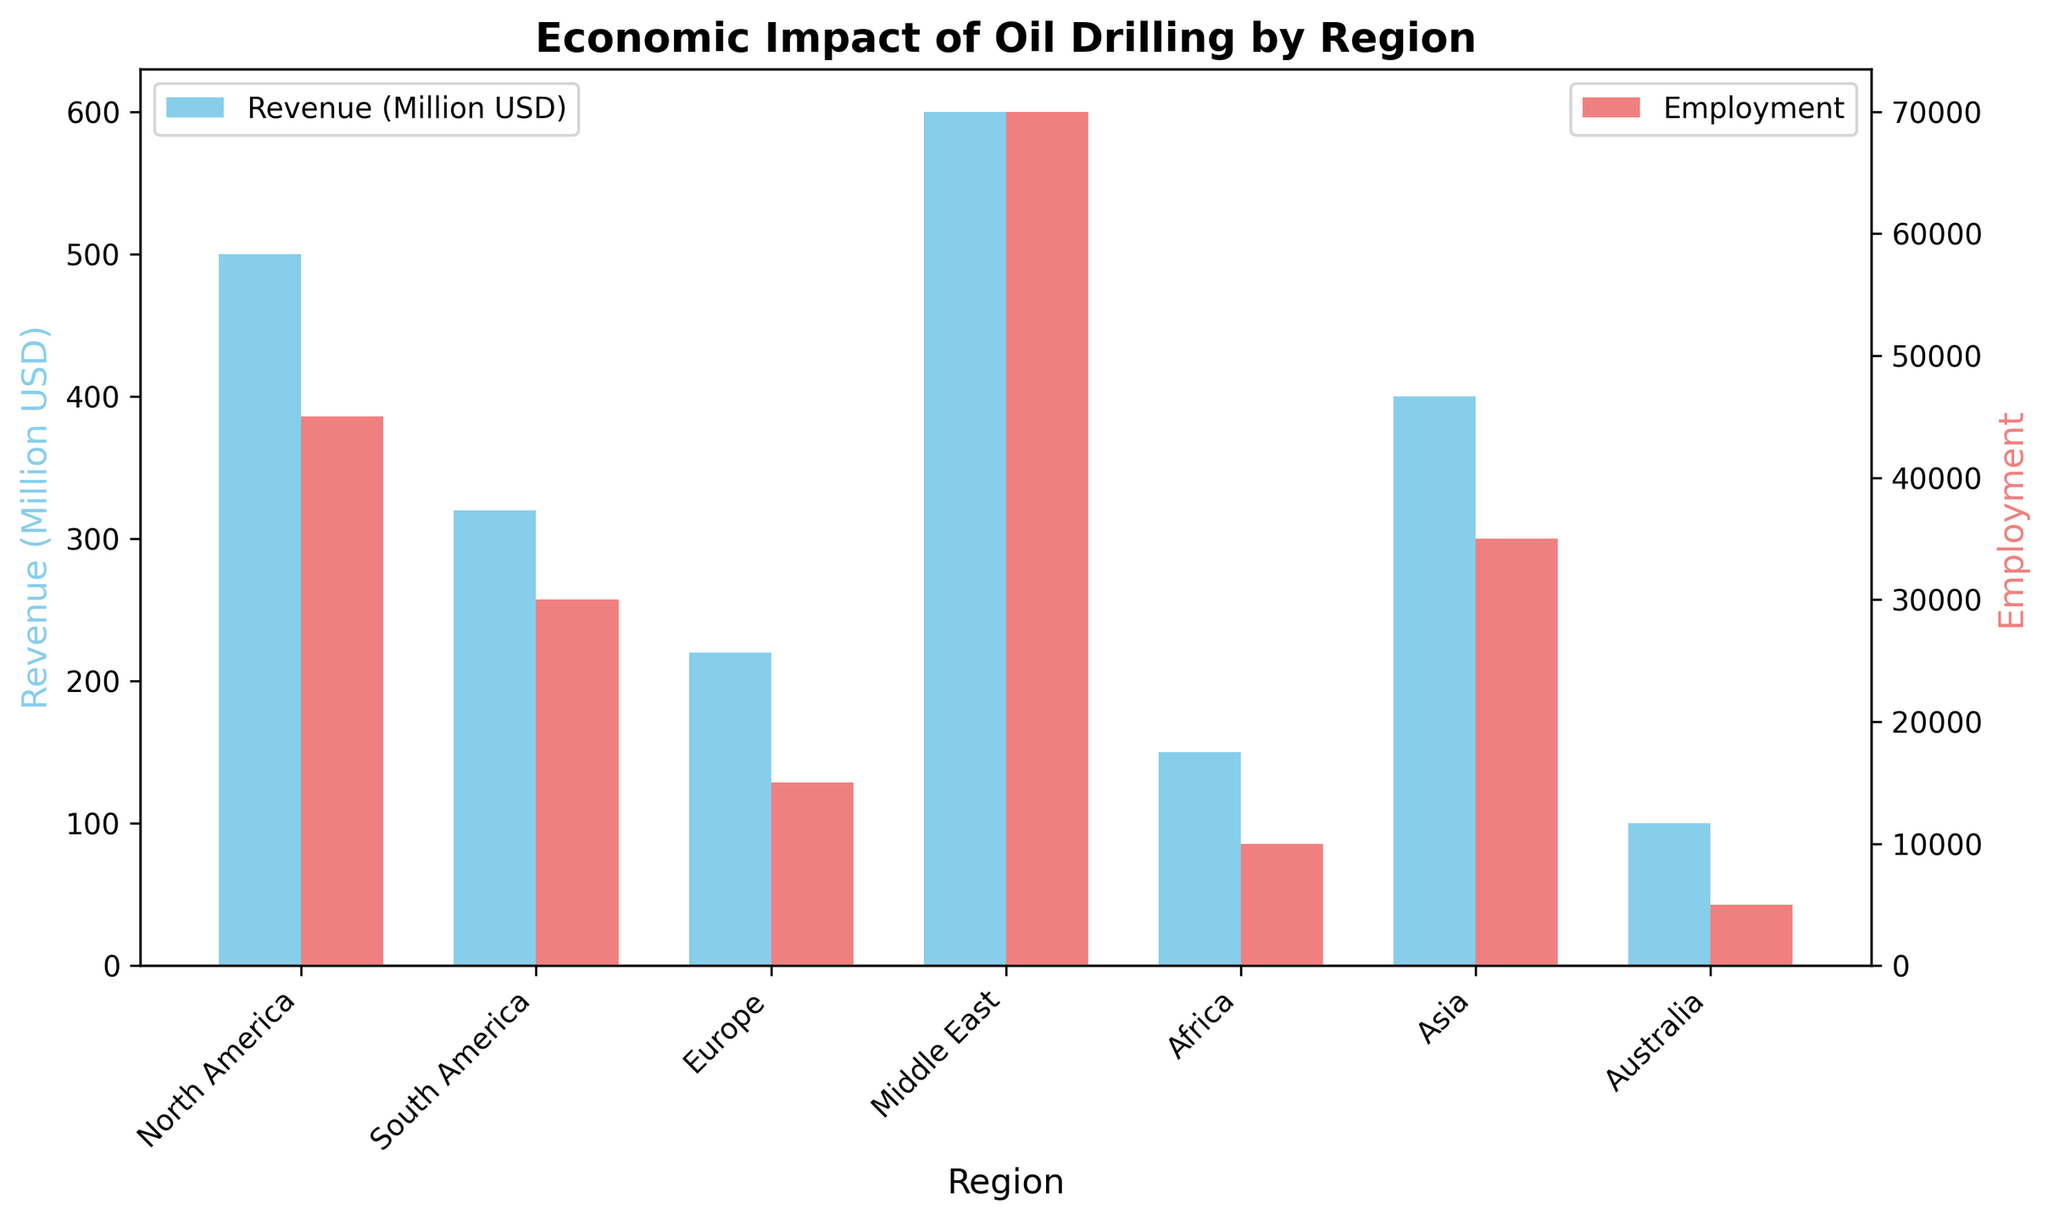Which region has the highest revenue? The region with the highest revenue is determined by looking at the tallest blue bar representing revenue in the bar chart. The Middle East has the highest revenue bar.
Answer: Middle East Which region has the lowest employment? The region with the lowest employment is identified by finding the shortest red bar representing employment in the bar chart. Australia has the shortest employment bar.
Answer: Australia What is the total revenue of North America and Asia combined? To determine the total revenue of North America and Asia, sum the revenue values shown for both regions: 500 (North America) + 400 (Asia) = 900 million USD.
Answer: 900 million USD Which region has more employment, Europe or Africa? Compare the lengths of the red bars for Europe and Africa. The red bar for Europe representing employment is taller than the one for Africa.
Answer: Europe How much more revenue does North America generate compared to Europe? Subtract the revenue of Europe from North America's revenue: 500 (North America) - 220 (Europe) = 280 million USD.
Answer: 280 million USD Which region has the closest revenue to South America? Compare the blue bars to see which is the closest in height to South America's revenue bar. Asia, with a revenue of 400 million USD, is closest to South America's 320.
Answer: Asia What is the total employment for the regions in Africa and Australia? Add the employment values for Africa and Australia: 10,000 (Africa) + 5,000 (Australia) = 15,000.
Answer: 15,000 How does the employment in Asia compare to the revenue in Europe? Look at the red bar for Asia and the blue bar for Europe. Employment in Asia is 35,000, while revenue in Europe is 220 million USD. Thus, employment in Asia is significantly higher compared to revenue in Europe when considering different metrics.
Answer: Employment in Asia is higher (in absolute terms) Which two regions have the smallest combined revenue? Identify the two regions with the smallest blue bars and add their revenues: Africa (150 million USD) and Australia (100 million USD) together make 150 + 100 = 250 million USD.
Answer: Africa and Australia 